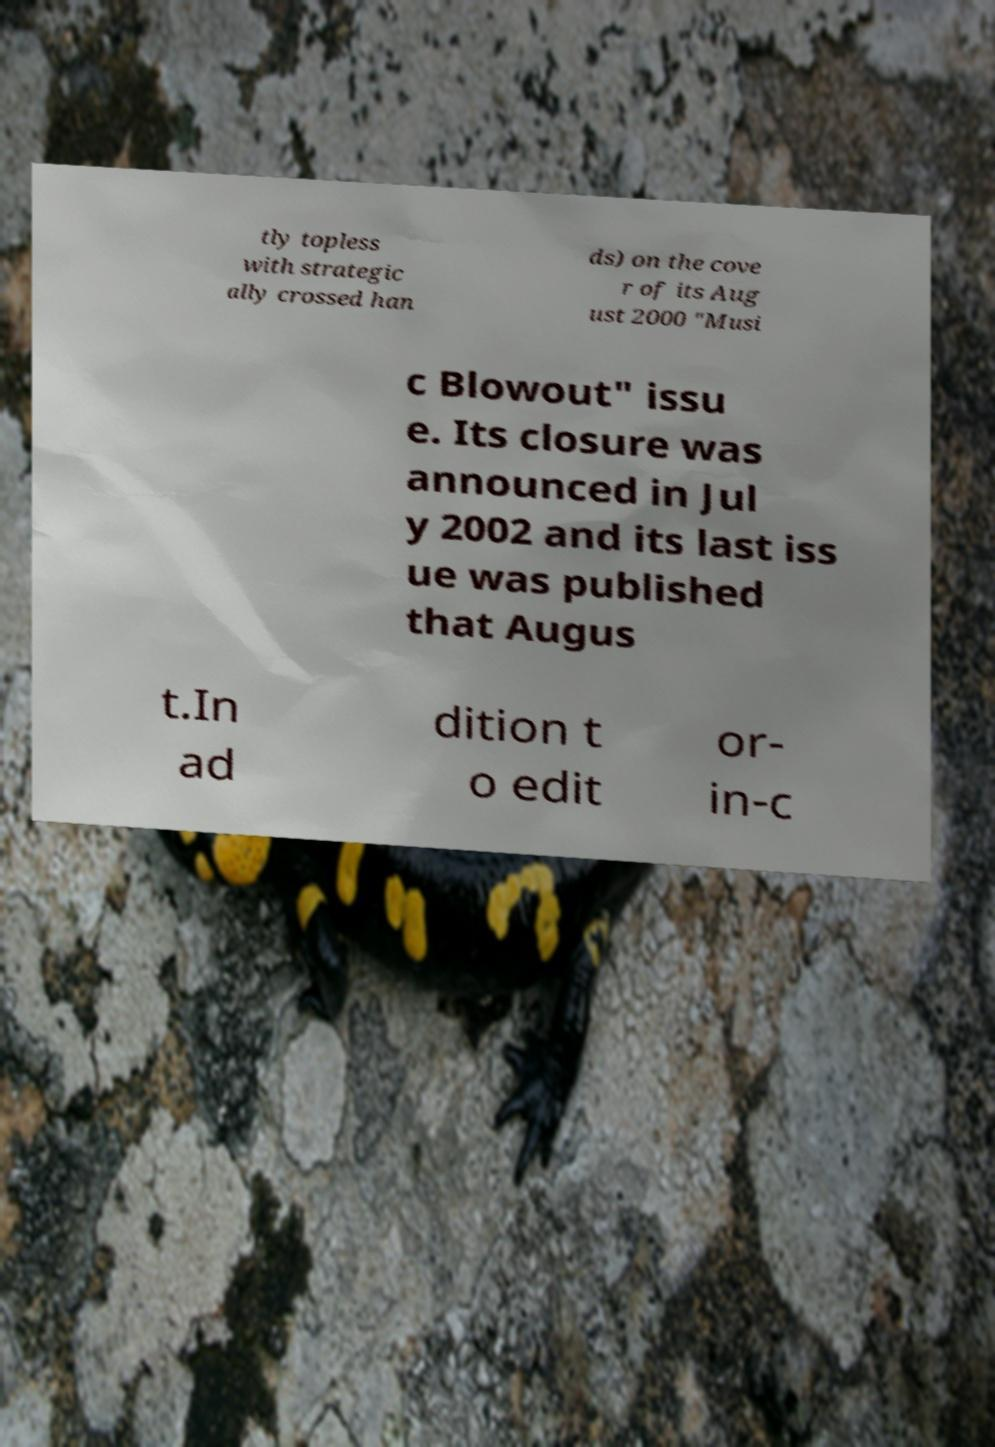Can you accurately transcribe the text from the provided image for me? tly topless with strategic ally crossed han ds) on the cove r of its Aug ust 2000 "Musi c Blowout" issu e. Its closure was announced in Jul y 2002 and its last iss ue was published that Augus t.In ad dition t o edit or- in-c 